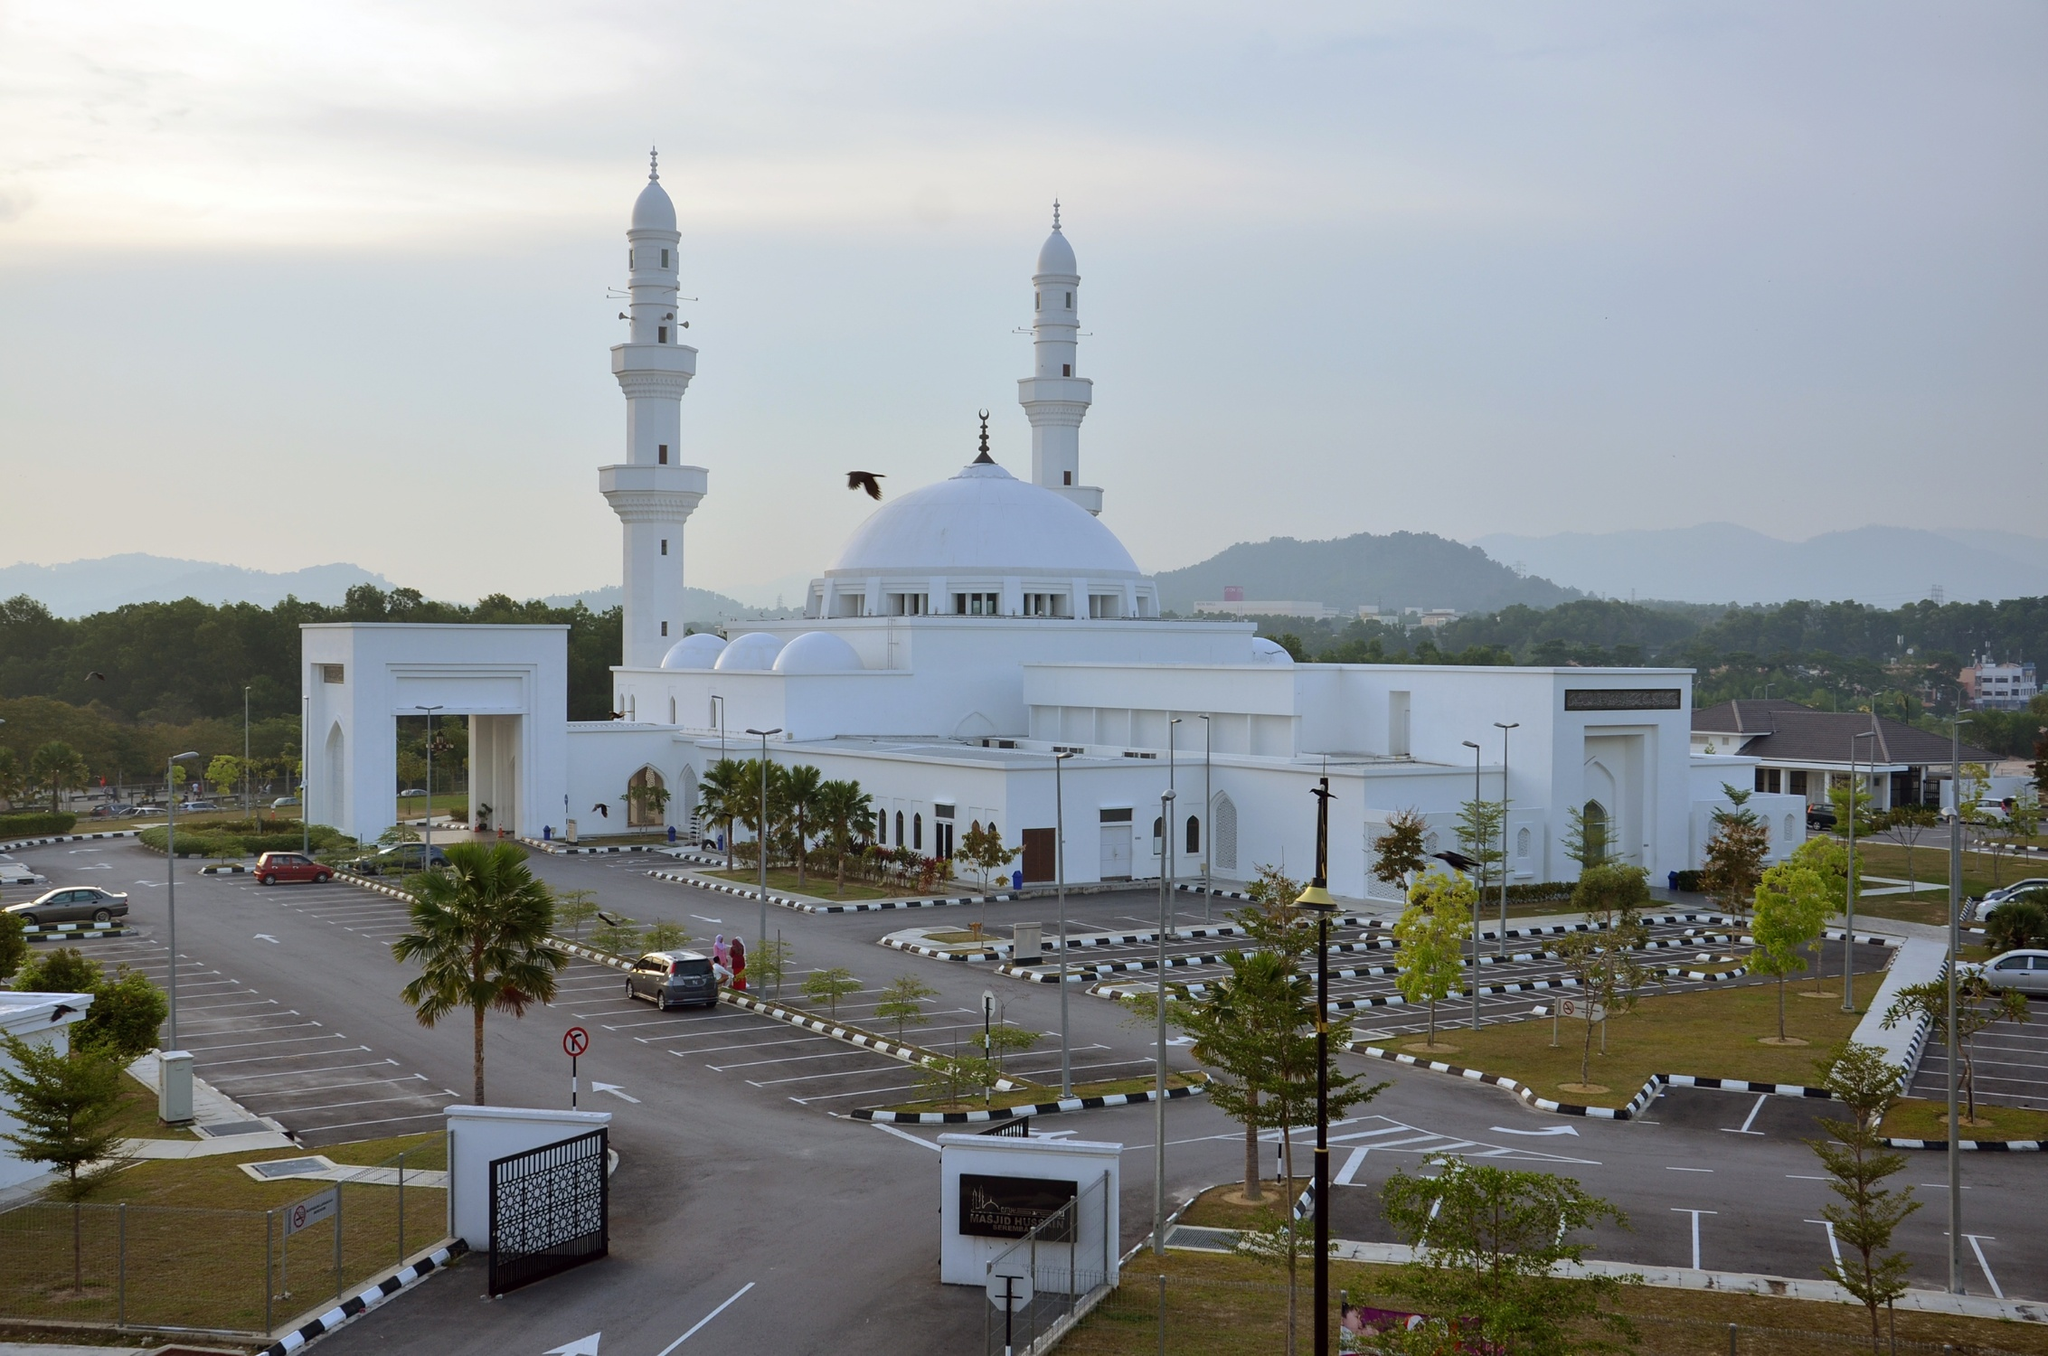How is this mosque important to the local community? This mosque, the Tengku Ampuan Jemaah Mosque, plays a crucial role in the spiritual and social life of the local Muslim community in Bukit Jelutong. It is not only a place for daily prayers but also a hub for communal activities, including educational programs and charitable events. During significant Islamic holidays, such as Ramadan and Eid, the mosque becomes a focal point for celebrations and gatherings, reinforcing bonds of community and faith. Its presence underscores the rich cultural tapestry of the area and provides a tranquil space for reflection and connection. 